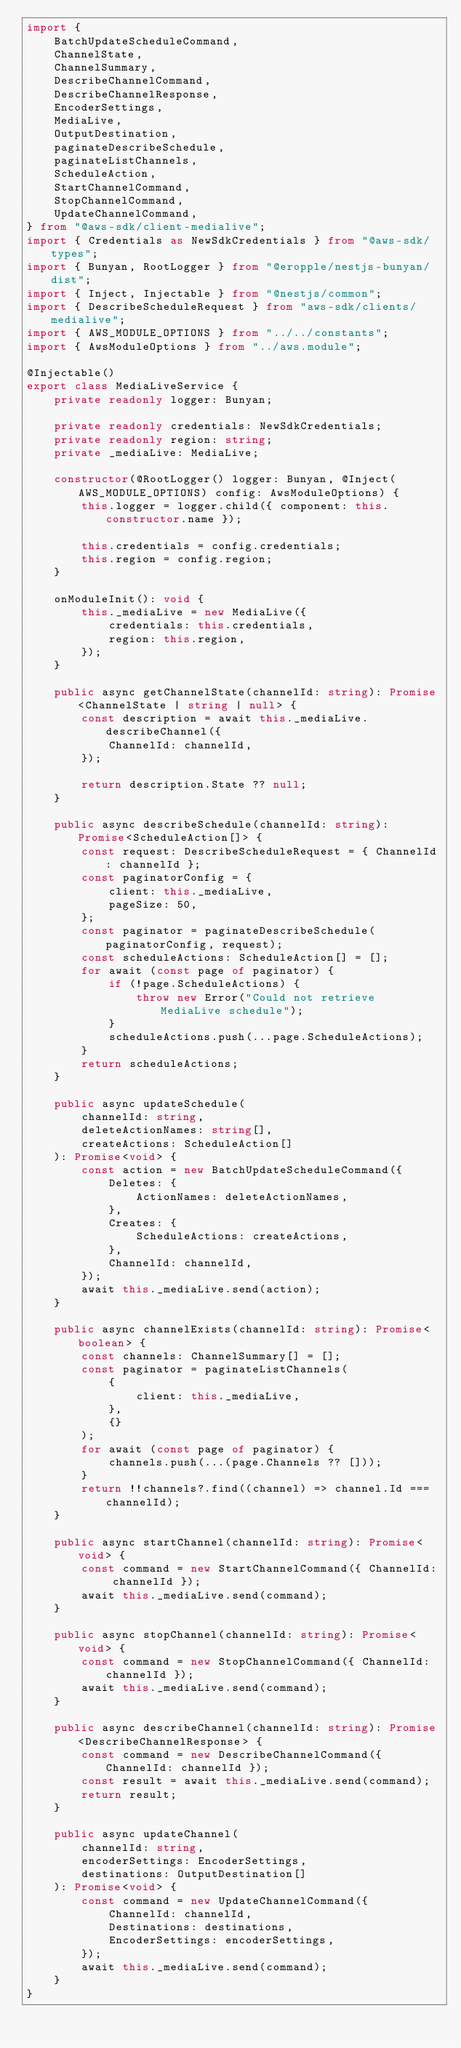<code> <loc_0><loc_0><loc_500><loc_500><_TypeScript_>import {
    BatchUpdateScheduleCommand,
    ChannelState,
    ChannelSummary,
    DescribeChannelCommand,
    DescribeChannelResponse,
    EncoderSettings,
    MediaLive,
    OutputDestination,
    paginateDescribeSchedule,
    paginateListChannels,
    ScheduleAction,
    StartChannelCommand,
    StopChannelCommand,
    UpdateChannelCommand,
} from "@aws-sdk/client-medialive";
import { Credentials as NewSdkCredentials } from "@aws-sdk/types";
import { Bunyan, RootLogger } from "@eropple/nestjs-bunyan/dist";
import { Inject, Injectable } from "@nestjs/common";
import { DescribeScheduleRequest } from "aws-sdk/clients/medialive";
import { AWS_MODULE_OPTIONS } from "../../constants";
import { AwsModuleOptions } from "../aws.module";

@Injectable()
export class MediaLiveService {
    private readonly logger: Bunyan;

    private readonly credentials: NewSdkCredentials;
    private readonly region: string;
    private _mediaLive: MediaLive;

    constructor(@RootLogger() logger: Bunyan, @Inject(AWS_MODULE_OPTIONS) config: AwsModuleOptions) {
        this.logger = logger.child({ component: this.constructor.name });

        this.credentials = config.credentials;
        this.region = config.region;
    }

    onModuleInit(): void {
        this._mediaLive = new MediaLive({
            credentials: this.credentials,
            region: this.region,
        });
    }

    public async getChannelState(channelId: string): Promise<ChannelState | string | null> {
        const description = await this._mediaLive.describeChannel({
            ChannelId: channelId,
        });

        return description.State ?? null;
    }

    public async describeSchedule(channelId: string): Promise<ScheduleAction[]> {
        const request: DescribeScheduleRequest = { ChannelId: channelId };
        const paginatorConfig = {
            client: this._mediaLive,
            pageSize: 50,
        };
        const paginator = paginateDescribeSchedule(paginatorConfig, request);
        const scheduleActions: ScheduleAction[] = [];
        for await (const page of paginator) {
            if (!page.ScheduleActions) {
                throw new Error("Could not retrieve MediaLive schedule");
            }
            scheduleActions.push(...page.ScheduleActions);
        }
        return scheduleActions;
    }

    public async updateSchedule(
        channelId: string,
        deleteActionNames: string[],
        createActions: ScheduleAction[]
    ): Promise<void> {
        const action = new BatchUpdateScheduleCommand({
            Deletes: {
                ActionNames: deleteActionNames,
            },
            Creates: {
                ScheduleActions: createActions,
            },
            ChannelId: channelId,
        });
        await this._mediaLive.send(action);
    }

    public async channelExists(channelId: string): Promise<boolean> {
        const channels: ChannelSummary[] = [];
        const paginator = paginateListChannels(
            {
                client: this._mediaLive,
            },
            {}
        );
        for await (const page of paginator) {
            channels.push(...(page.Channels ?? []));
        }
        return !!channels?.find((channel) => channel.Id === channelId);
    }

    public async startChannel(channelId: string): Promise<void> {
        const command = new StartChannelCommand({ ChannelId: channelId });
        await this._mediaLive.send(command);
    }

    public async stopChannel(channelId: string): Promise<void> {
        const command = new StopChannelCommand({ ChannelId: channelId });
        await this._mediaLive.send(command);
    }

    public async describeChannel(channelId: string): Promise<DescribeChannelResponse> {
        const command = new DescribeChannelCommand({ ChannelId: channelId });
        const result = await this._mediaLive.send(command);
        return result;
    }

    public async updateChannel(
        channelId: string,
        encoderSettings: EncoderSettings,
        destinations: OutputDestination[]
    ): Promise<void> {
        const command = new UpdateChannelCommand({
            ChannelId: channelId,
            Destinations: destinations,
            EncoderSettings: encoderSettings,
        });
        await this._mediaLive.send(command);
    }
}
</code> 